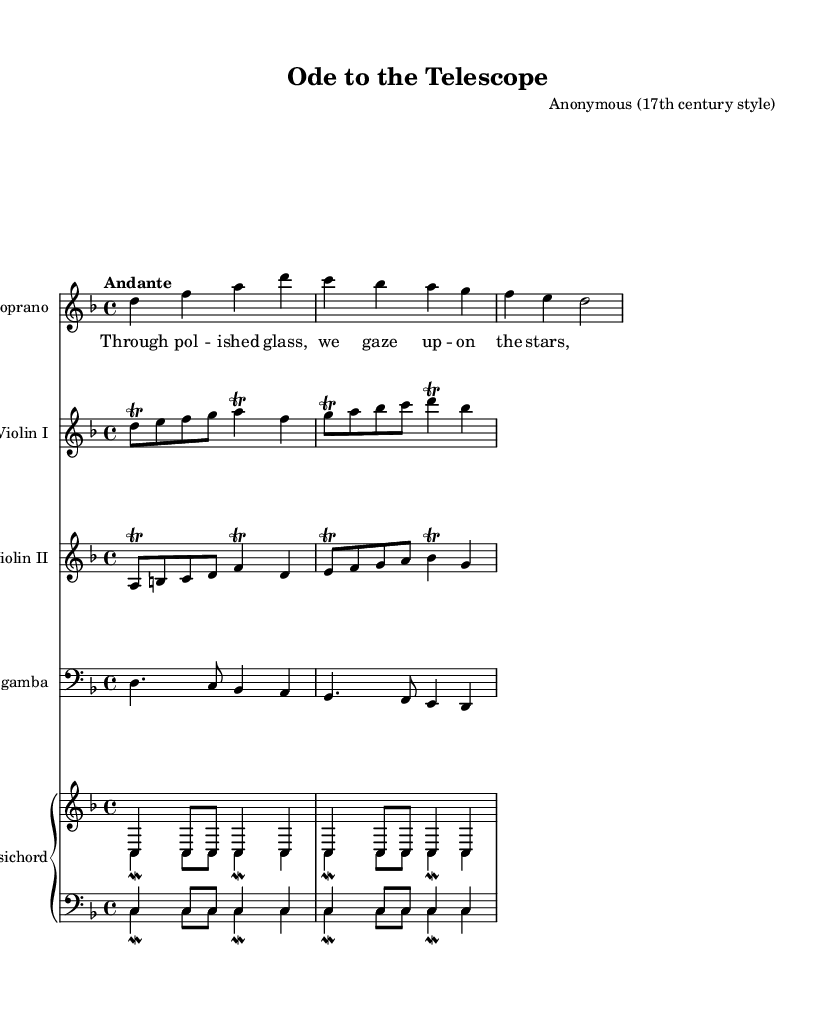What is the key signature of this music? The key signature is D minor, which has one flat. This is identified by the two flattened B notes in the music, indicating the key's tonality.
Answer: D minor What is the time signature of this music? The time signature is 4/4, as indicated at the beginning of the score. This means there are four beats in each measure.
Answer: 4/4 What is the tempo marking in the score? The tempo marking is "Andante", which suggests a moderate walking pace. This is usually found at the start of the score.
Answer: Andante How many instruments are featured in this piece? There are five instruments featured in this piece: Soprano, Violin I, Violin II, Viola da gamba, and Harpsichord. This can be determined by counting the number of staves in the score.
Answer: Five Which instrument has a trill in the first measure? The instrument with a trill in the first measure is Violin I. This is visible by the trill symbol placed on the note within the staff line.
Answer: Violin I What vocal line is present in this cantata? The vocal line present is for the Soprano, as indicated by the voice part labeled in the score.
Answer: Soprano What historical context does the title suggest about the piece? The title "Ode to the Telescope" suggests a celebratory context related to scientific discovery, specifically astronomy and the advances made during the 17th century. This is inferred from the title's reference to the telescope.
Answer: Scientific discovery 